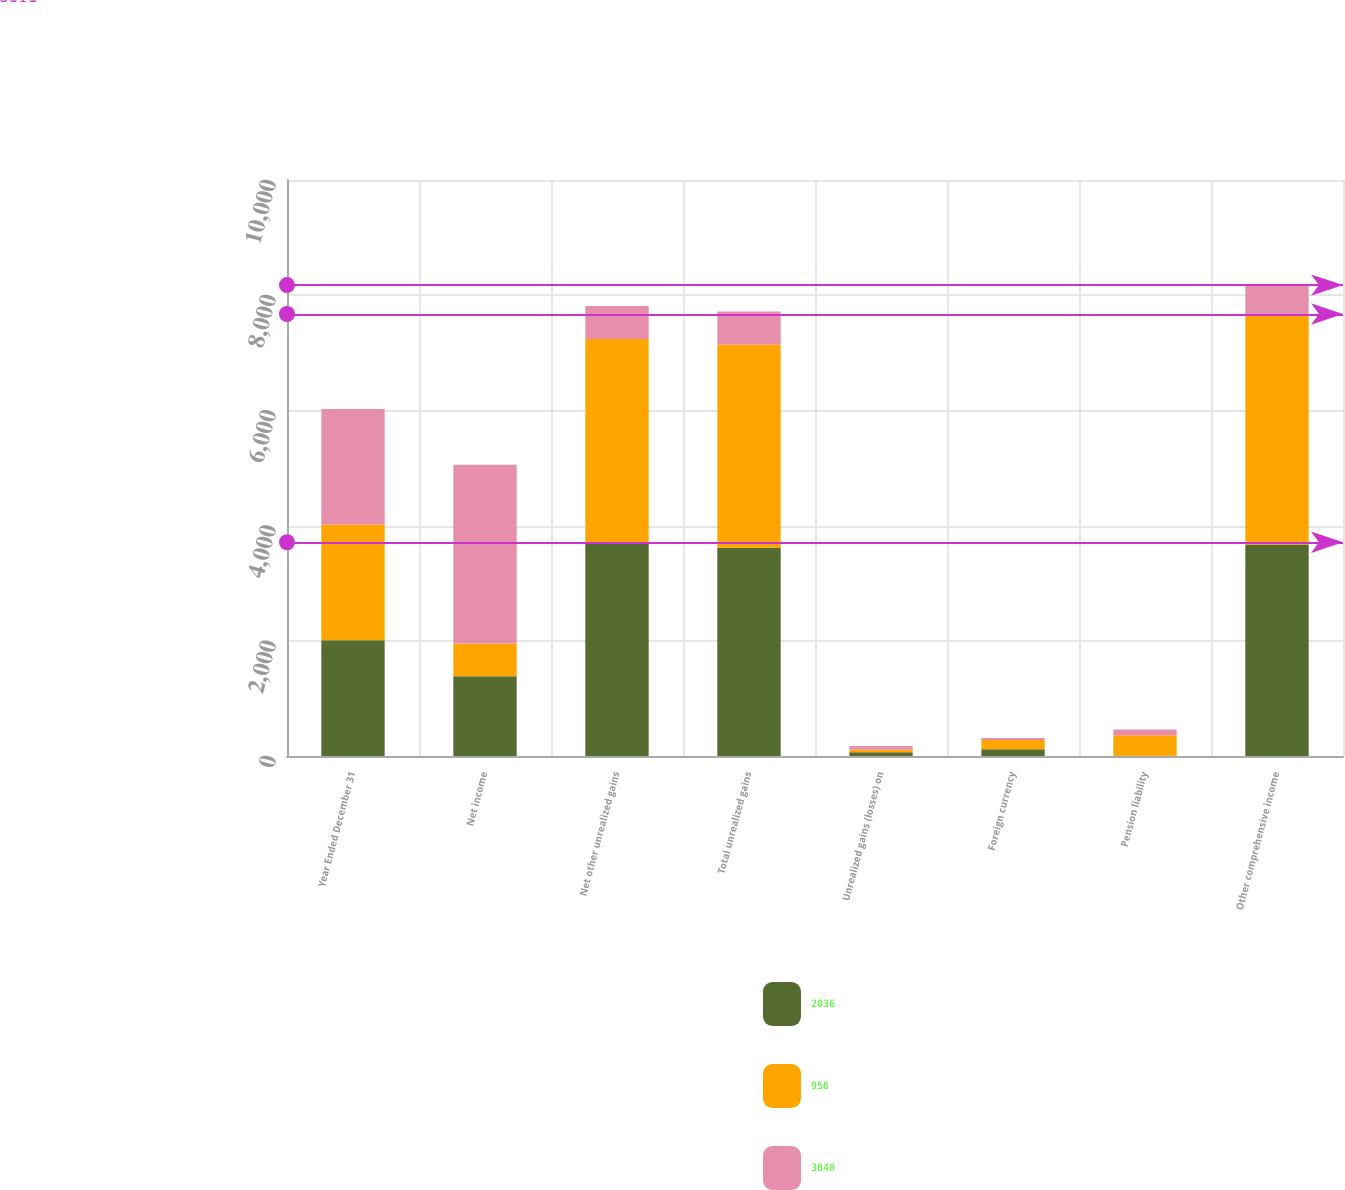Convert chart. <chart><loc_0><loc_0><loc_500><loc_500><stacked_bar_chart><ecel><fcel>Year Ended December 31<fcel>Net income<fcel>Net other unrealized gains<fcel>Total unrealized gains<fcel>Unrealized gains (losses) on<fcel>Foreign currency<fcel>Pension liability<fcel>Other comprehensive income<nl><fcel>2036<fcel>2009<fcel>1383<fcel>3711<fcel>3616<fcel>67<fcel>117<fcel>6<fcel>3672<nl><fcel>956<fcel>2008<fcel>572<fcel>3528<fcel>3528<fcel>41<fcel>161<fcel>354<fcel>4002<nl><fcel>3840<fcel>2007<fcel>3100<fcel>572<fcel>572<fcel>65<fcel>35<fcel>100<fcel>502<nl></chart> 